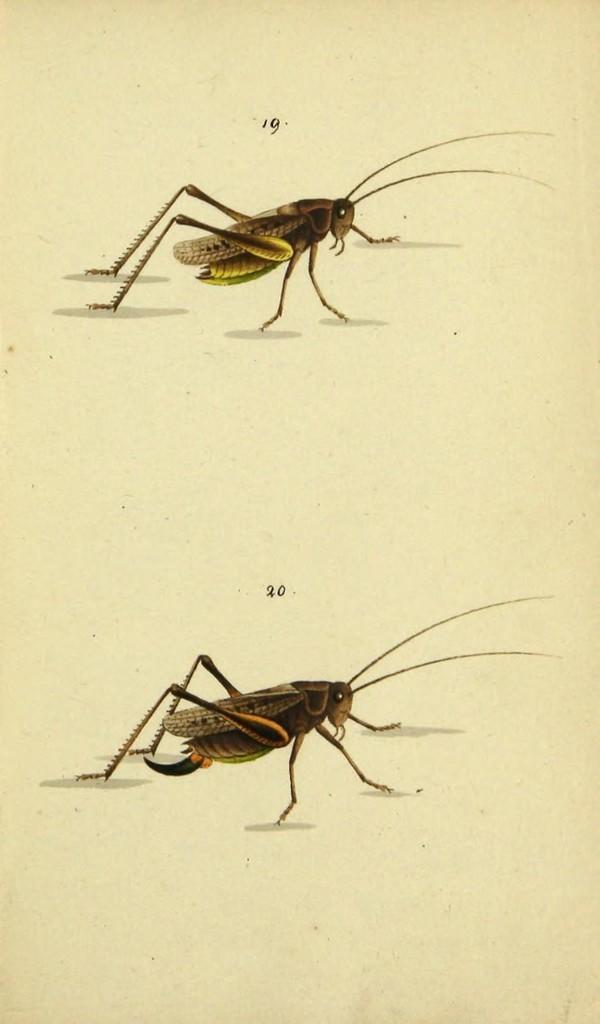How would you summarize this image in a sentence or two? In the picture we can see a paper on it we can see a painting of two insects with antenna, legs, eyes and wings. 